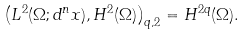<formula> <loc_0><loc_0><loc_500><loc_500>\left ( L ^ { 2 } ( \Omega ; d ^ { n } x ) , H ^ { 2 } ( \Omega ) \right ) _ { q , 2 } = H ^ { 2 q } ( \Omega ) .</formula> 